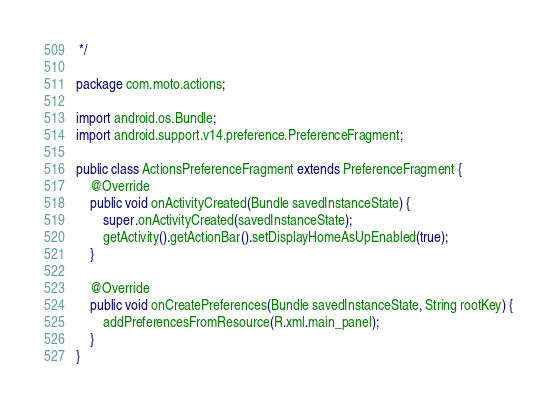Convert code to text. <code><loc_0><loc_0><loc_500><loc_500><_Java_> */

package com.moto.actions;

import android.os.Bundle;
import android.support.v14.preference.PreferenceFragment;

public class ActionsPreferenceFragment extends PreferenceFragment {
    @Override
    public void onActivityCreated(Bundle savedInstanceState) {
        super.onActivityCreated(savedInstanceState);
        getActivity().getActionBar().setDisplayHomeAsUpEnabled(true);
    }

    @Override
    public void onCreatePreferences(Bundle savedInstanceState, String rootKey) {
        addPreferencesFromResource(R.xml.main_panel);
    }
}
</code> 